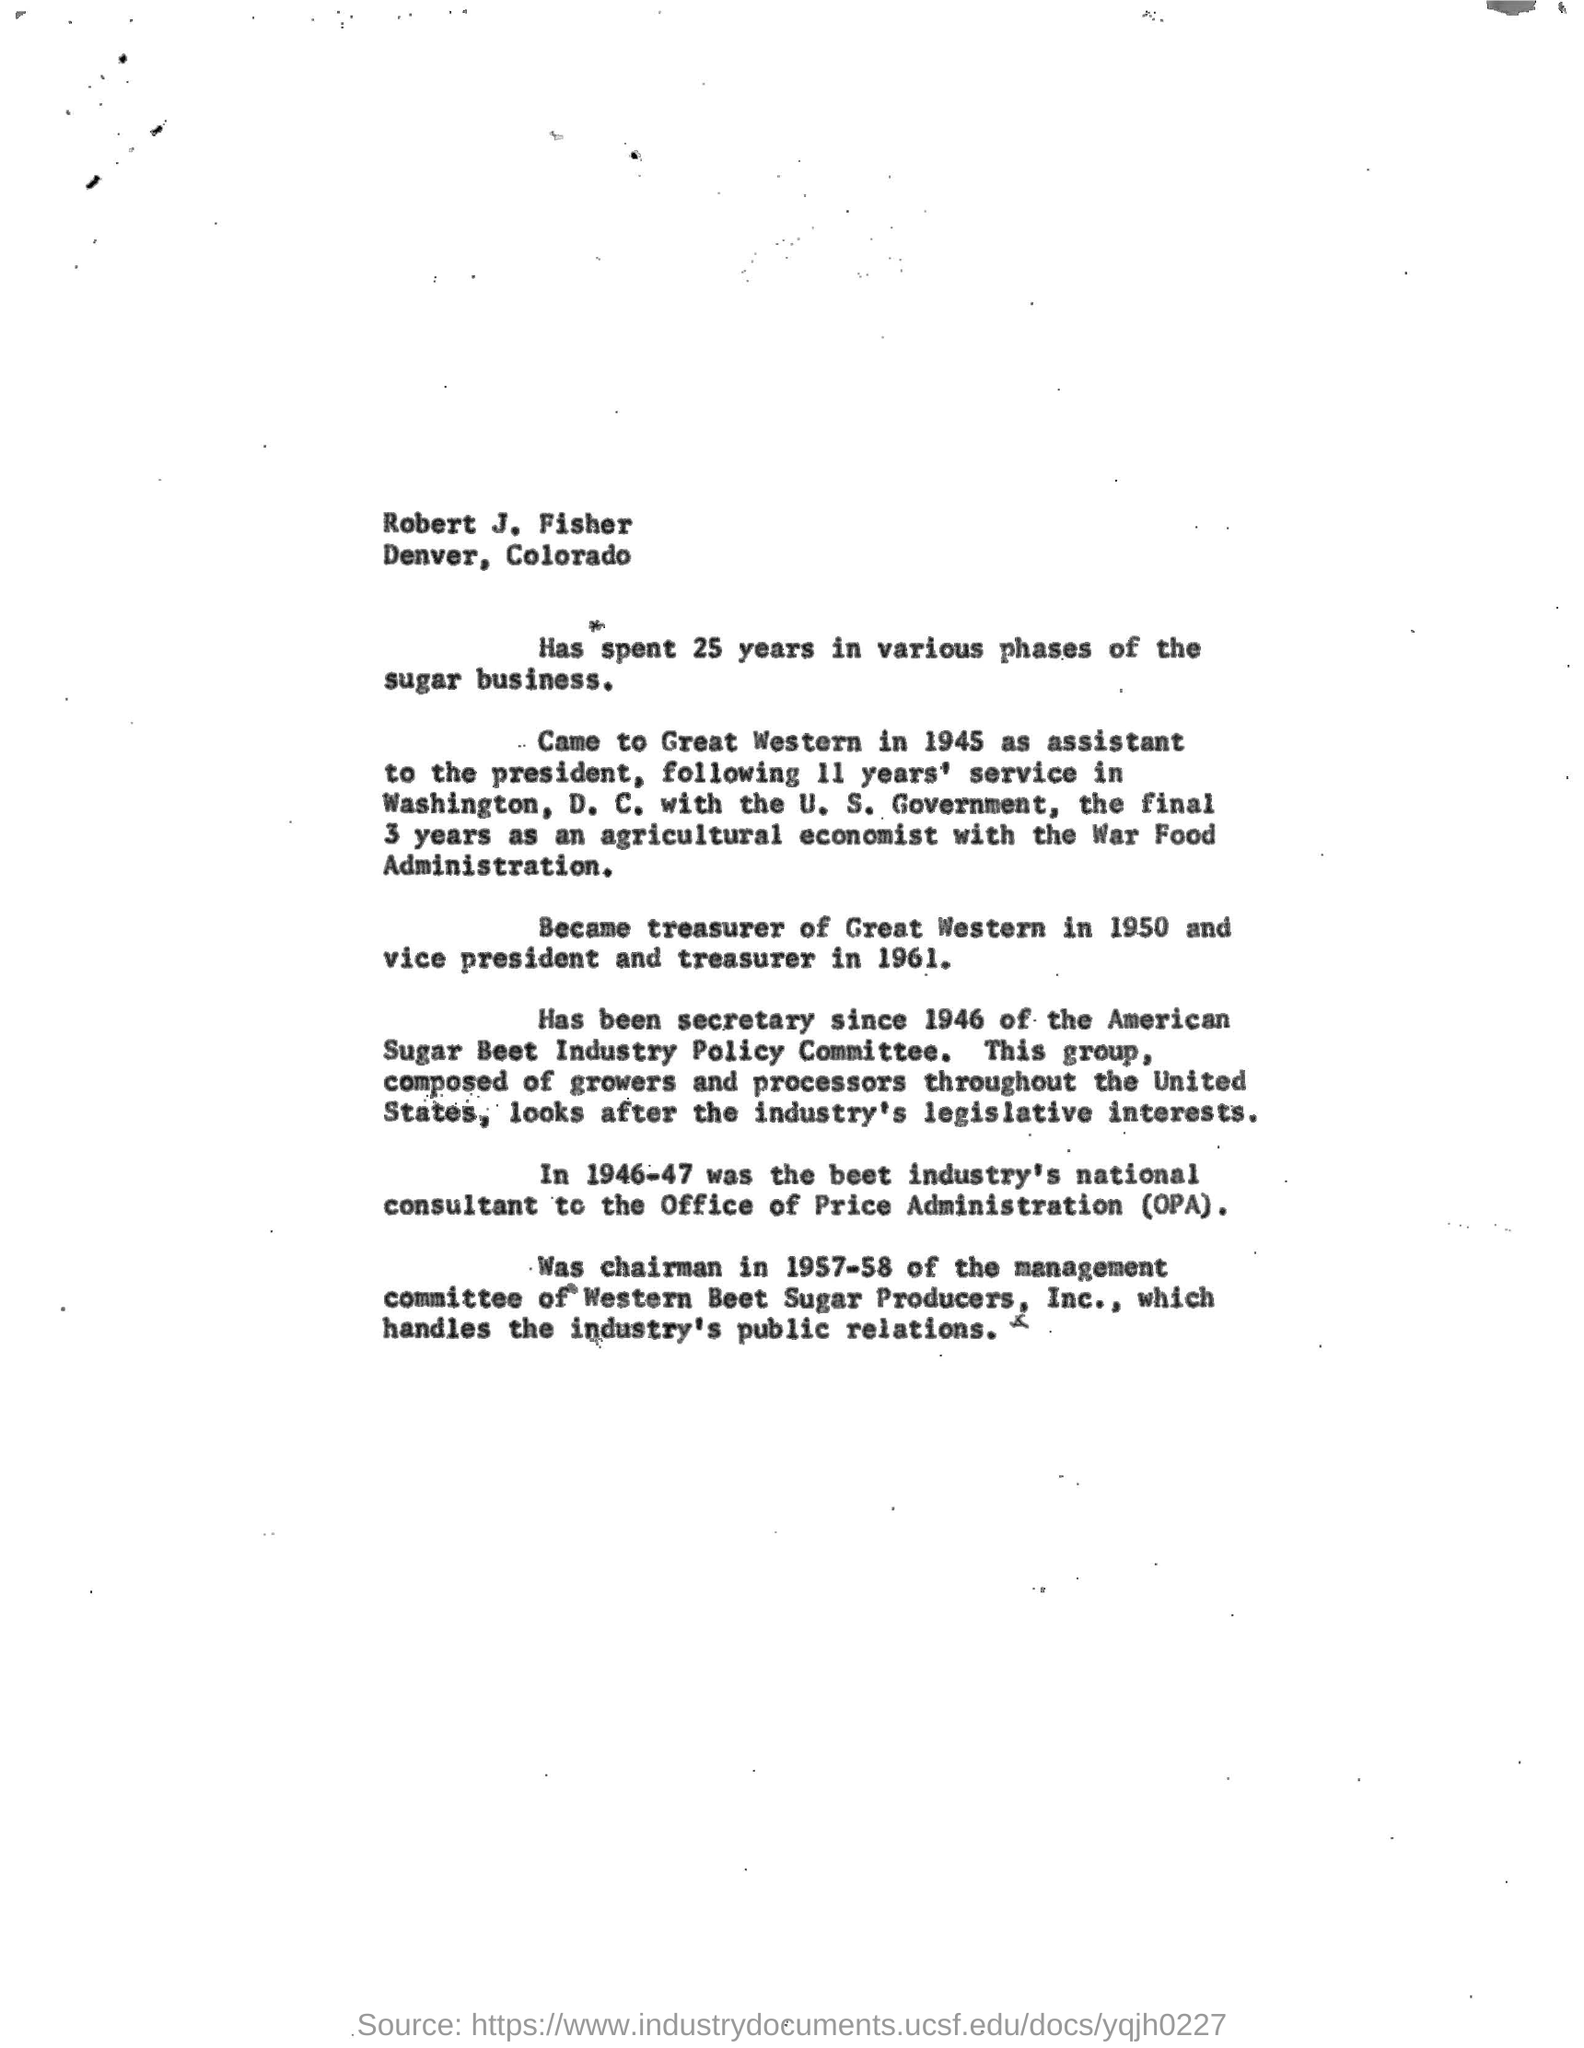What is the location of robert j. fisher?
Offer a terse response. Denver, Colorado. How many years robert j. fisher spent in various phases of the sugar business?
Give a very brief answer. 25. To where he came to join as a  president for 11 years service in washington ,d.c with u.s. government?
Your answer should be compact. Great Western. Final 3 years as an agricultural economist with which administration he serviced?
Provide a short and direct response. War Food Administration. To which administration robert j. fisher became the beet industry's national consultant?
Ensure brevity in your answer.  Office of Price Administration. When he became chairman for the management committee of western beet sugar producer, inc.,?
Give a very brief answer. In 1957-58. What he handles as a chariman for the management committee of western beet sugar producer, inc.?
Your answer should be compact. The industry's public relations. 